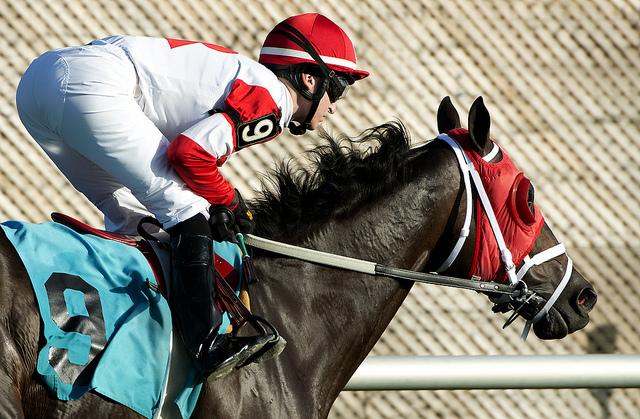What is his number?
Answer briefly. 9. Is the man standing?
Write a very short answer. No. What is the guy riding on?
Write a very short answer. Horse. 